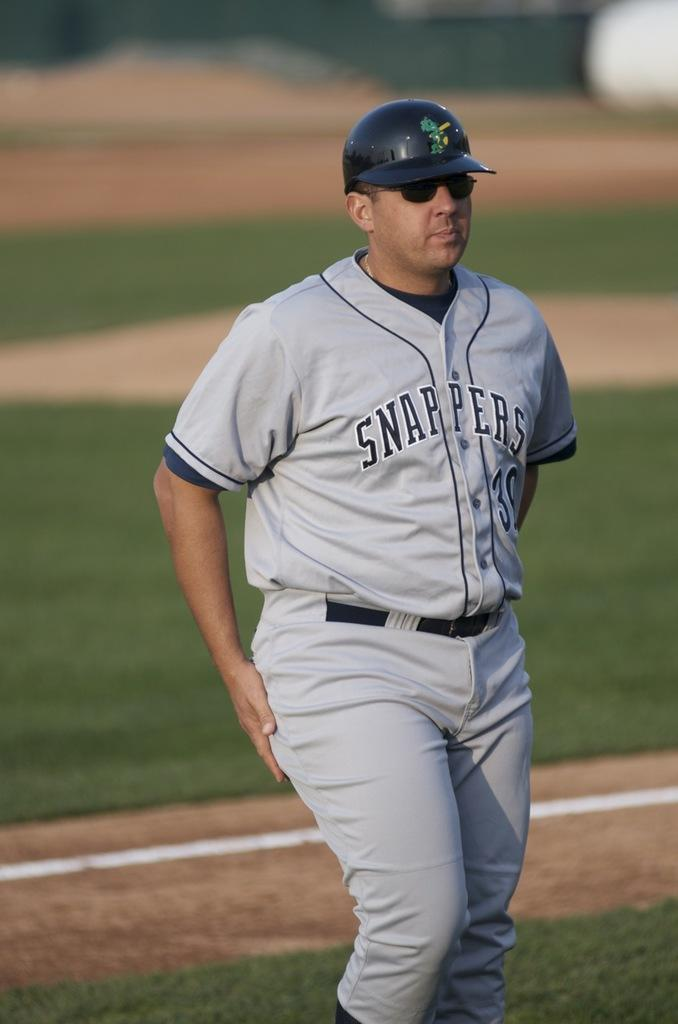<image>
Write a terse but informative summary of the picture. A coach wearing a Snappers uniform looks towards the dugout. 